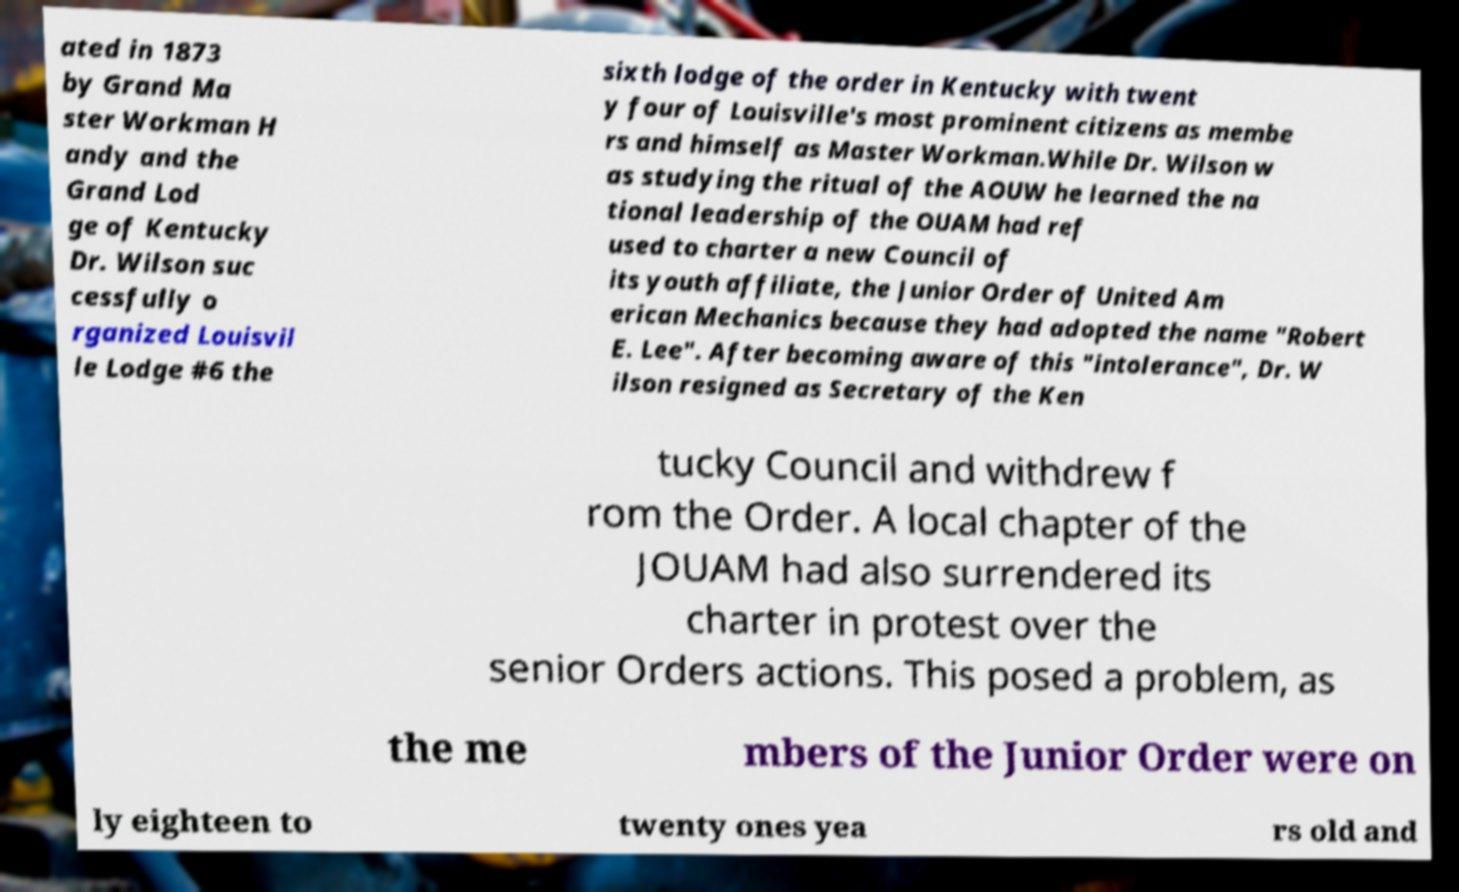Could you assist in decoding the text presented in this image and type it out clearly? ated in 1873 by Grand Ma ster Workman H andy and the Grand Lod ge of Kentucky Dr. Wilson suc cessfully o rganized Louisvil le Lodge #6 the sixth lodge of the order in Kentucky with twent y four of Louisville's most prominent citizens as membe rs and himself as Master Workman.While Dr. Wilson w as studying the ritual of the AOUW he learned the na tional leadership of the OUAM had ref used to charter a new Council of its youth affiliate, the Junior Order of United Am erican Mechanics because they had adopted the name "Robert E. Lee". After becoming aware of this "intolerance", Dr. W ilson resigned as Secretary of the Ken tucky Council and withdrew f rom the Order. A local chapter of the JOUAM had also surrendered its charter in protest over the senior Orders actions. This posed a problem, as the me mbers of the Junior Order were on ly eighteen to twenty ones yea rs old and 